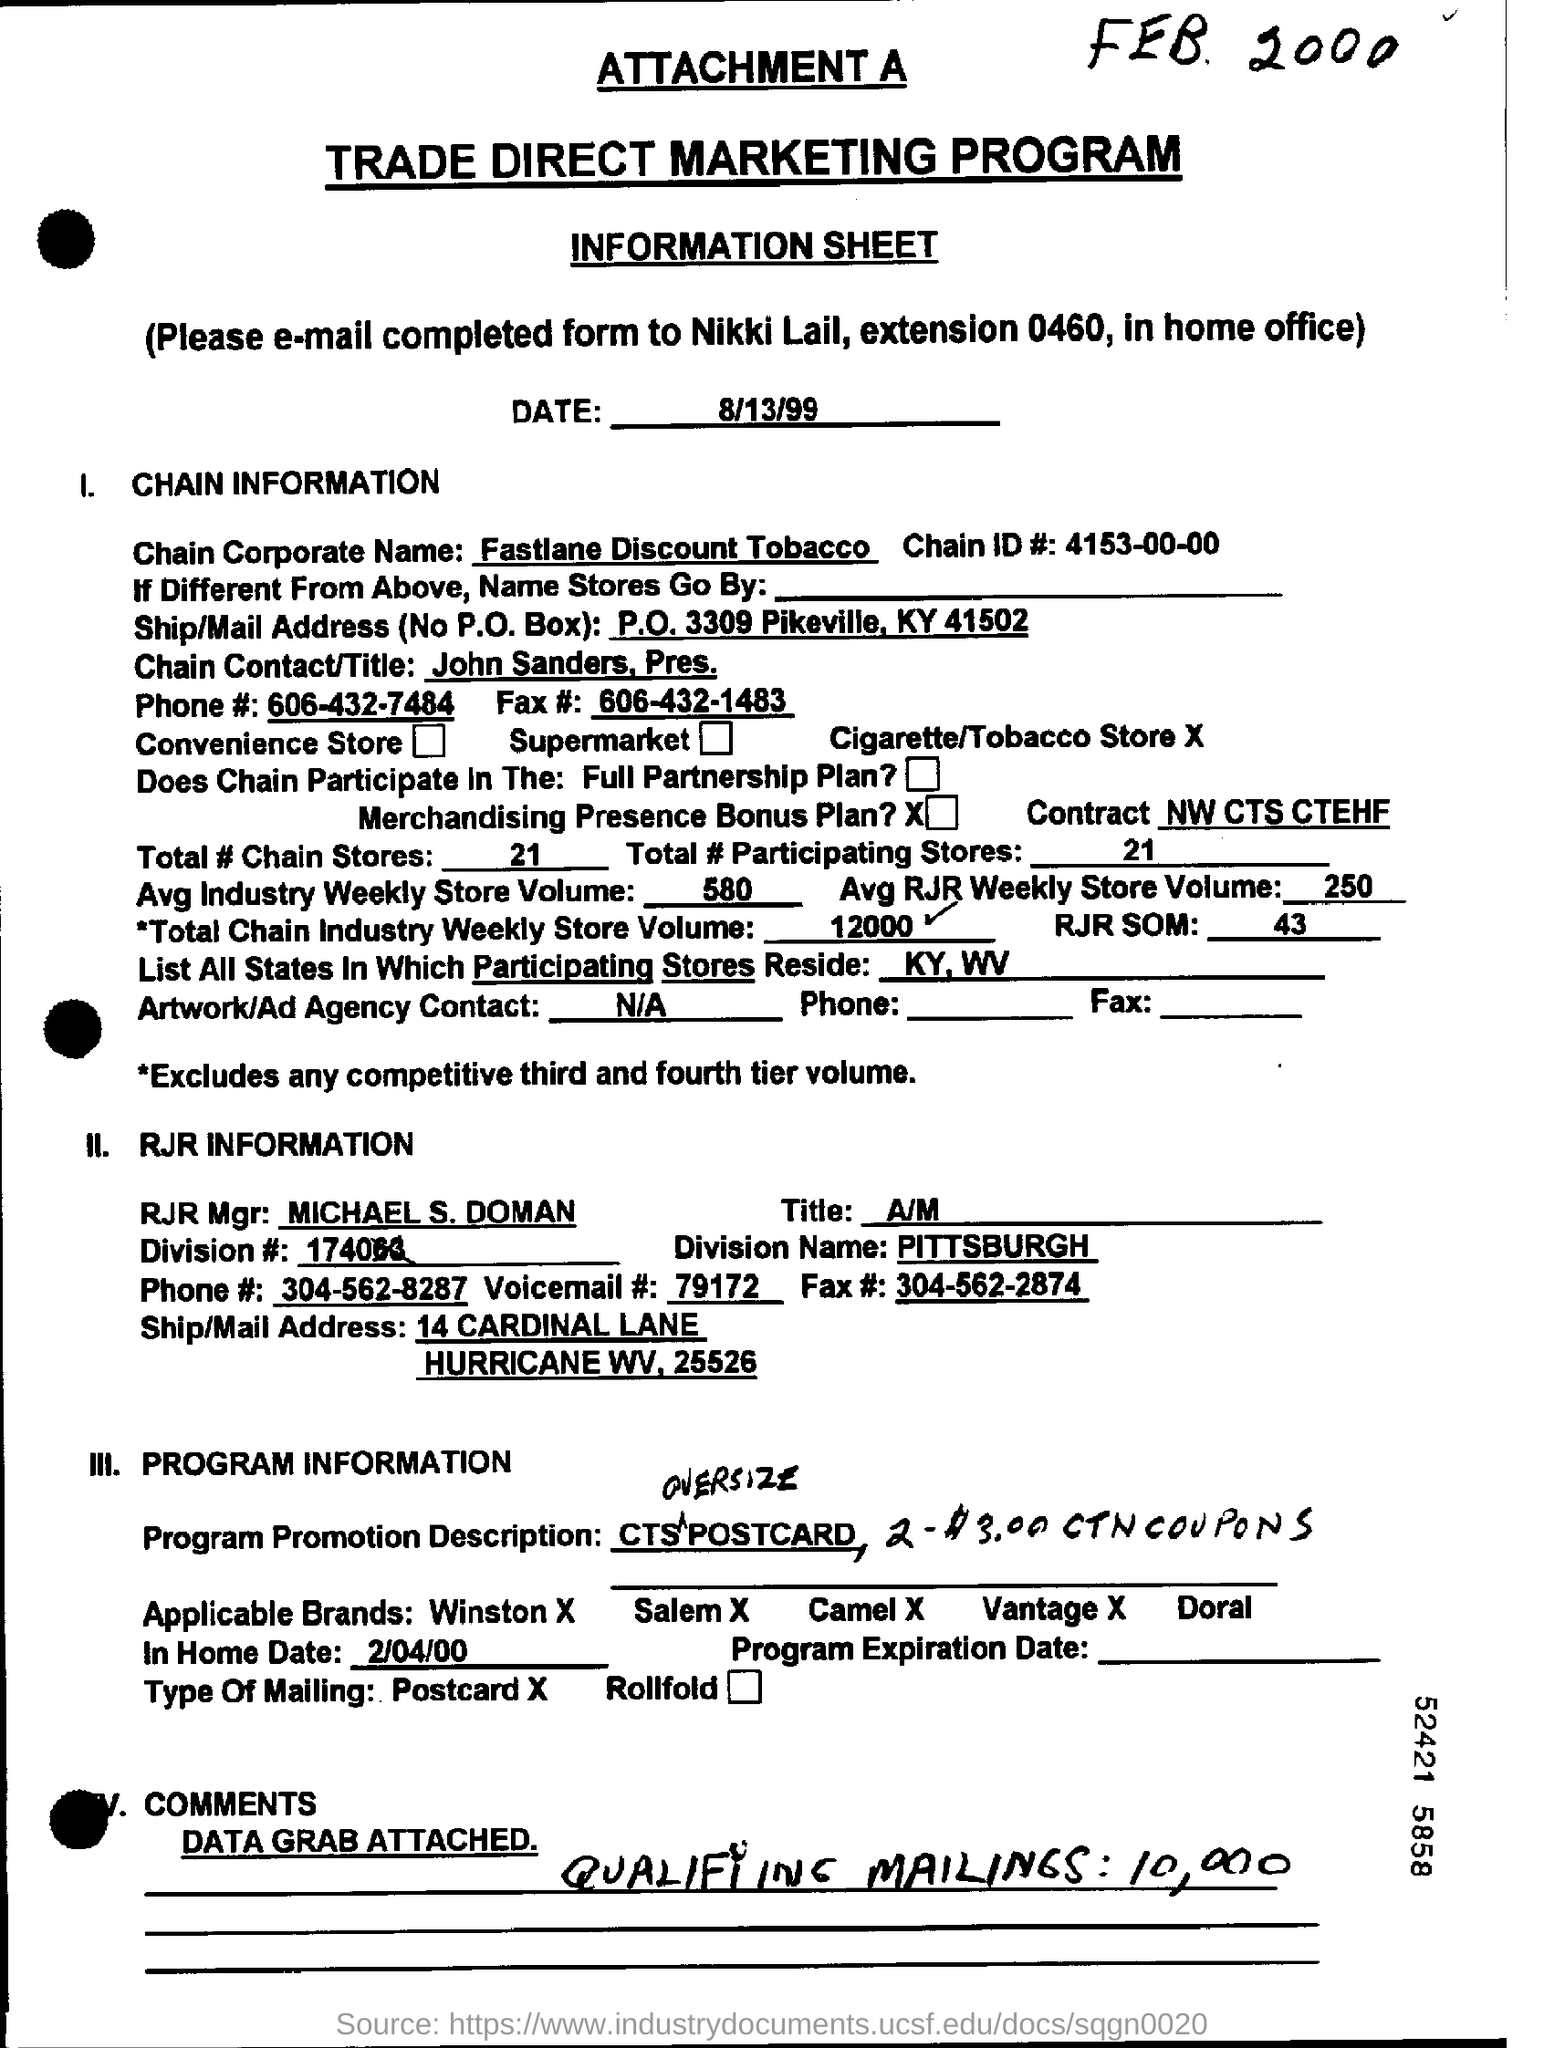What is the Date?
Provide a short and direct response. 8/13/99. What is the chain corporate name?
Your response must be concise. Fastlane Discount Tobacco. What is the Chain ID#?
Ensure brevity in your answer.  4153-00-00. What is the chain corporate name mentioned in the form?
Give a very brief answer. Fastlane Discount Tobacco. What is the Chain Contact/Title?
Your answer should be compact. John Sanders, Pres. What is the Phone #?
Your response must be concise. 606-432-7484. What is the Fax #?
Offer a very short reply. 606-432-1483. What is the Total # chain stores?
Your response must be concise. 21. What is the Total # participating stores?
Offer a terse response. 21. Who is the RJR Mgr?
Keep it short and to the point. Michael S. Doman. 